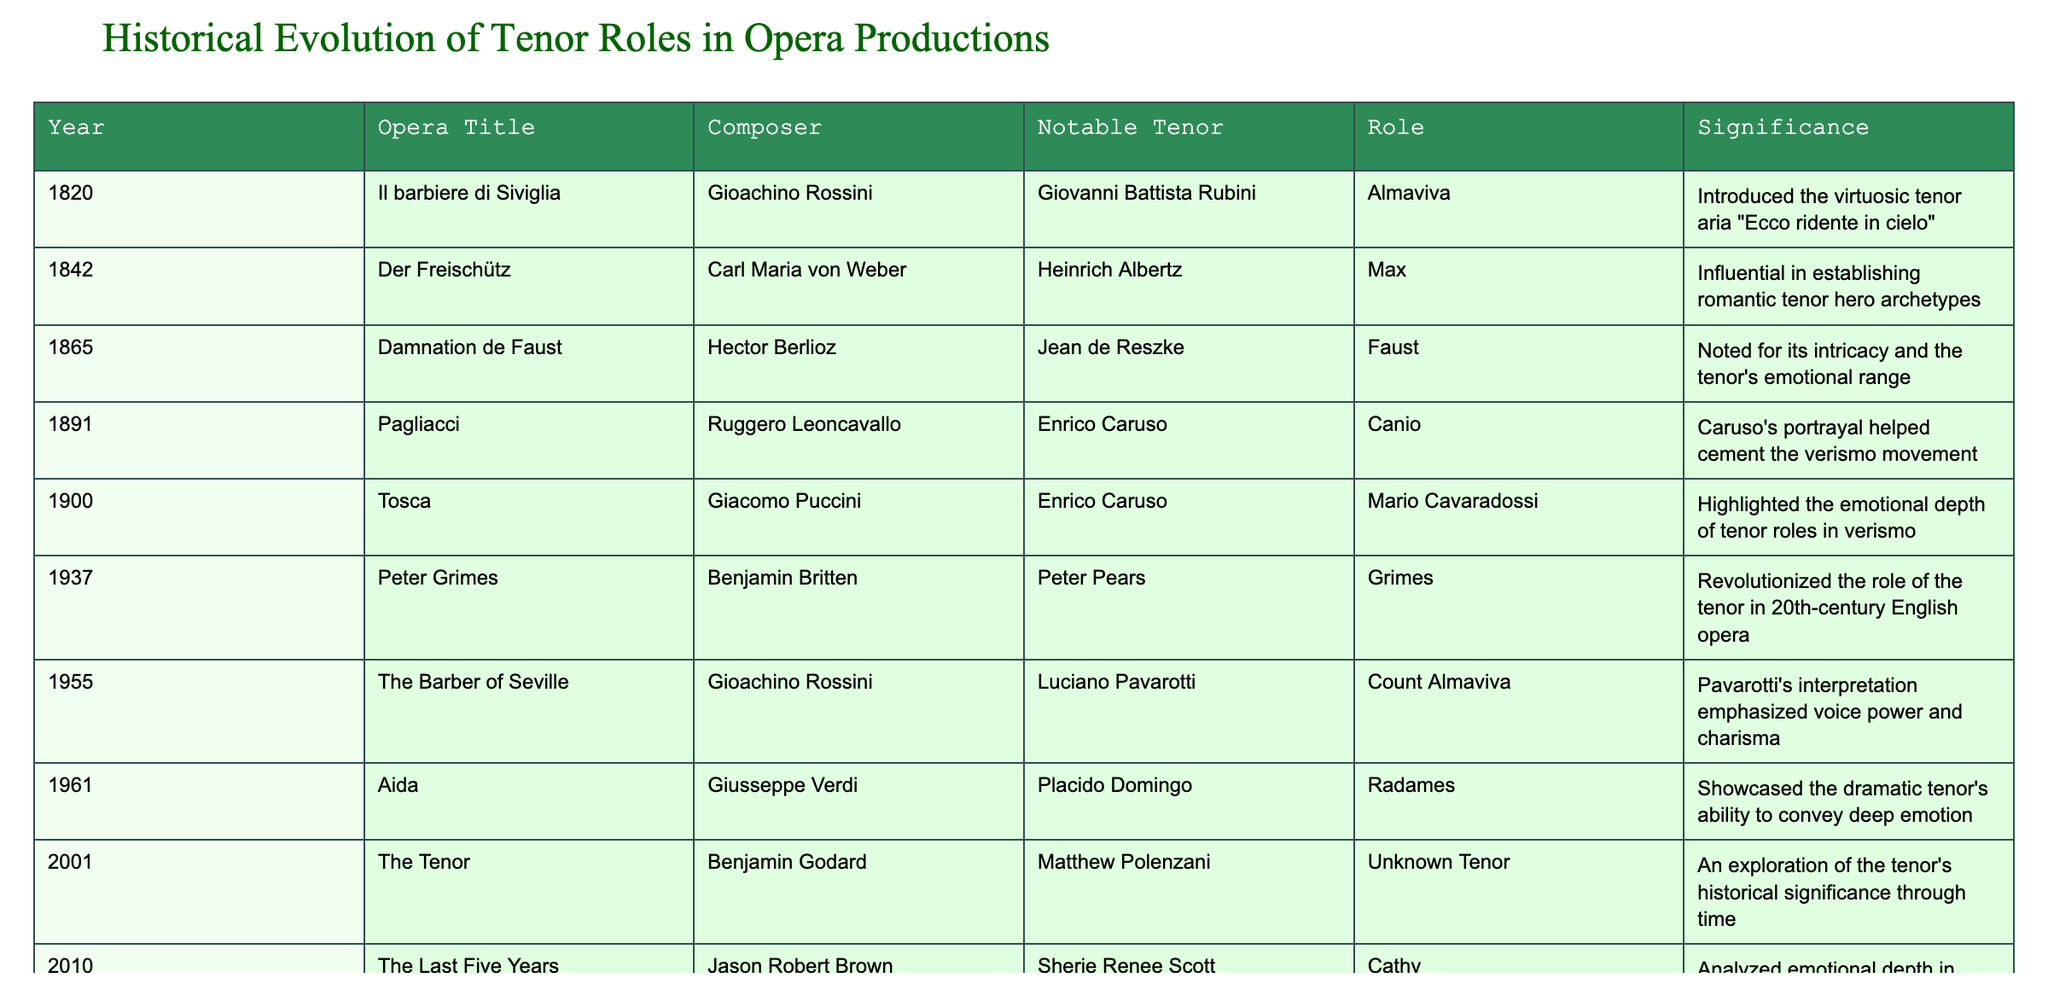What was the historical significance of Enrico Caruso's role in "Pagliacci"? Enrico Caruso played Canio in "Pagliacci," which was noted for Caruso's portrayal that helped cement the verismo movement in opera. This signifies his impact on the evolution of tenor roles, linking emotional performance with the style.
Answer: It helped cement the verismo movement Which composer is associated with the opera "Aida"? The opera "Aida" was composed by Giusseppe Verdi, as shown in the table under the respective year and title.
Answer: Giusseppe Verdi In which year did "Der Freischütz" premiere, and what role did it introduce for tenors? "Der Freischütz" premiered in 1842, introducing the romantic tenor hero archetype, as noted in the significance section of the table.
Answer: 1842; romantic tenor hero How many operas listed feature the tenor's emotional depth as a key part of their significance? Counting the rows for operas that emphasize emotional depth, both "Tosca" and "Damnation de Faust," highlight this aspect, resulting in a total of 2.
Answer: 2 True or False: "The Last Great Tenor" reflects on the challenges faced by tenor roles in modern opera. The description for "The Last Great Tenor" states it reflects on the challenges and evolution of tenor roles, confirming the statement as true.
Answer: True Which tenor showcased dramatic abilities in the role of Radames in "Aida"? The table specifies that Placido Domingo played Radames in "Aida," showcasing the dramatic tenor's abilities.
Answer: Placido Domingo What is the difference in years between the first opera listed and the last opera listed? The first opera listed is from 1820 and the last from 2020. Thus, the difference in years is 2020 - 1820 = 200 years.
Answer: 200 years Identify the notable tenor associated with "Peter Grimes" and describe its revolutionary aspect. The notable tenor for "Peter Grimes" is Peter Pears. The role revolutionized the tenor's role in 20th-century English opera, modifying expectations for tenor portrayals.
Answer: Peter Pears; revolutionized tenor's role in English opera How many opera titles in the table were composed in the 20th century? The operas "Peter Grimes" (1937) and "The Last Great Tenor" (2020) represent the 20th century, leading to a total of 2 operas.
Answer: 2 What aspect marked the 1900 opera "Tosca" concerning tenor roles? "Tosca" is marked for highlighting the emotional depth of tenor roles in the verismo style, making this aspect significant for tenor performance.
Answer: Emotional depth of tenor roles 